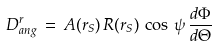Convert formula to latex. <formula><loc_0><loc_0><loc_500><loc_500>D ^ { r } _ { a n g } \, = \, A ( r _ { S } ) \, R ( r _ { S } ) \, \cos \, \psi \, \frac { d \Phi } { d \Theta }</formula> 